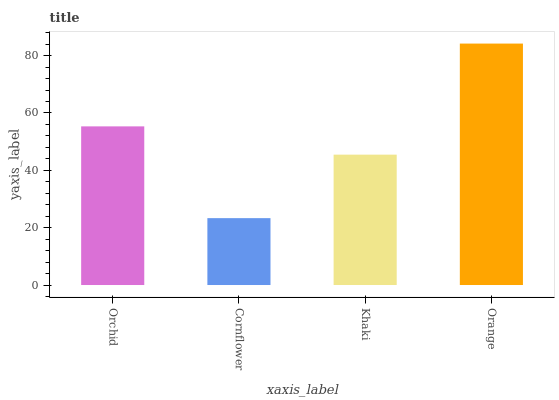Is Cornflower the minimum?
Answer yes or no. Yes. Is Orange the maximum?
Answer yes or no. Yes. Is Khaki the minimum?
Answer yes or no. No. Is Khaki the maximum?
Answer yes or no. No. Is Khaki greater than Cornflower?
Answer yes or no. Yes. Is Cornflower less than Khaki?
Answer yes or no. Yes. Is Cornflower greater than Khaki?
Answer yes or no. No. Is Khaki less than Cornflower?
Answer yes or no. No. Is Orchid the high median?
Answer yes or no. Yes. Is Khaki the low median?
Answer yes or no. Yes. Is Orange the high median?
Answer yes or no. No. Is Cornflower the low median?
Answer yes or no. No. 